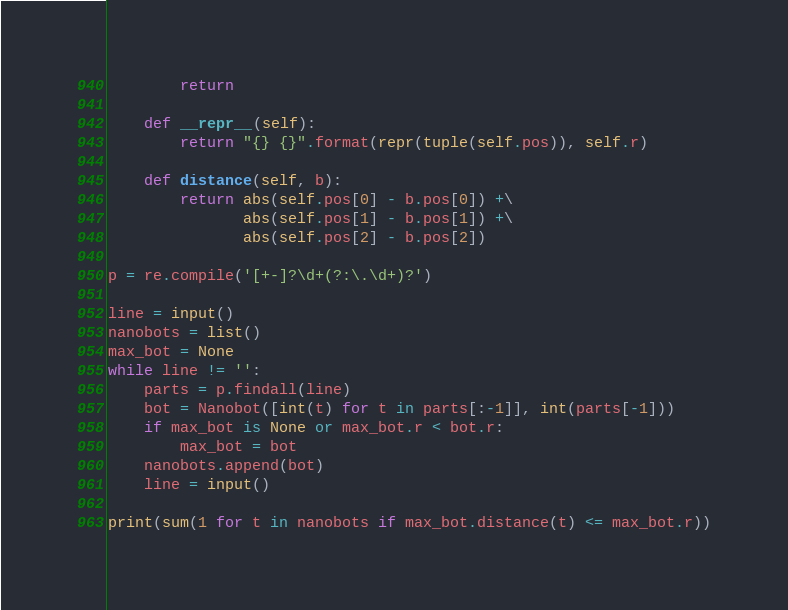<code> <loc_0><loc_0><loc_500><loc_500><_Python_>        return

    def __repr__(self):
        return "{} {}".format(repr(tuple(self.pos)), self.r)

    def distance(self, b):
        return abs(self.pos[0] - b.pos[0]) +\
               abs(self.pos[1] - b.pos[1]) +\
               abs(self.pos[2] - b.pos[2])

p = re.compile('[+-]?\d+(?:\.\d+)?')

line = input()
nanobots = list()
max_bot = None
while line != '':
    parts = p.findall(line)
    bot = Nanobot([int(t) for t in parts[:-1]], int(parts[-1]))
    if max_bot is None or max_bot.r < bot.r:
        max_bot = bot
    nanobots.append(bot)
    line = input()

print(sum(1 for t in nanobots if max_bot.distance(t) <= max_bot.r))
</code> 